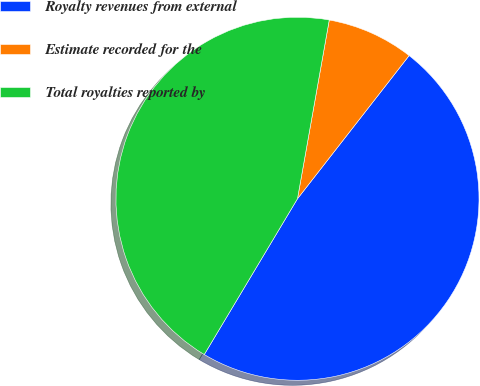Convert chart. <chart><loc_0><loc_0><loc_500><loc_500><pie_chart><fcel>Royalty revenues from external<fcel>Estimate recorded for the<fcel>Total royalties reported by<nl><fcel>48.04%<fcel>7.74%<fcel>44.22%<nl></chart> 